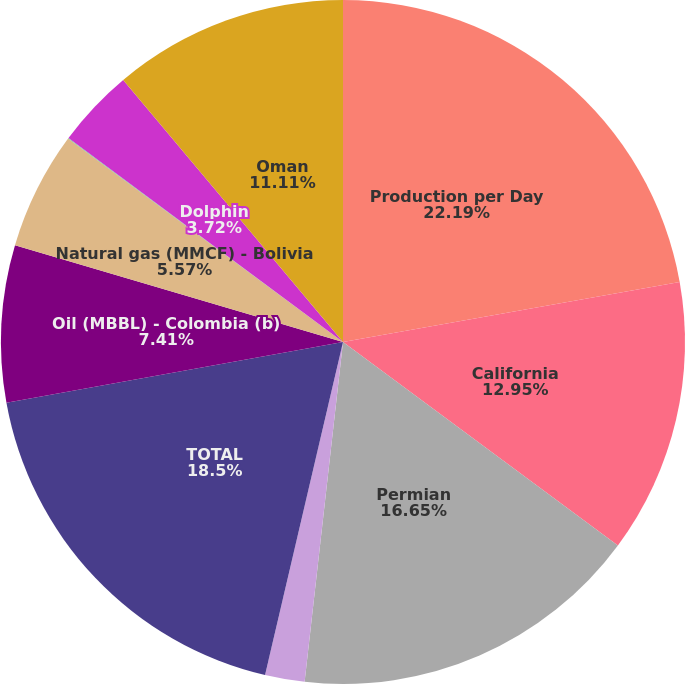Convert chart to OTSL. <chart><loc_0><loc_0><loc_500><loc_500><pie_chart><fcel>Production per Day<fcel>California<fcel>Permian<fcel>Midcontinent and Other<fcel>TOTAL<fcel>Oil (MBBL) - Colombia (b)<fcel>Natural gas (MMCF) - Bolivia<fcel>Bahrain<fcel>Dolphin<fcel>Oman<nl><fcel>22.19%<fcel>12.95%<fcel>16.65%<fcel>1.87%<fcel>18.5%<fcel>7.41%<fcel>5.57%<fcel>0.03%<fcel>3.72%<fcel>11.11%<nl></chart> 